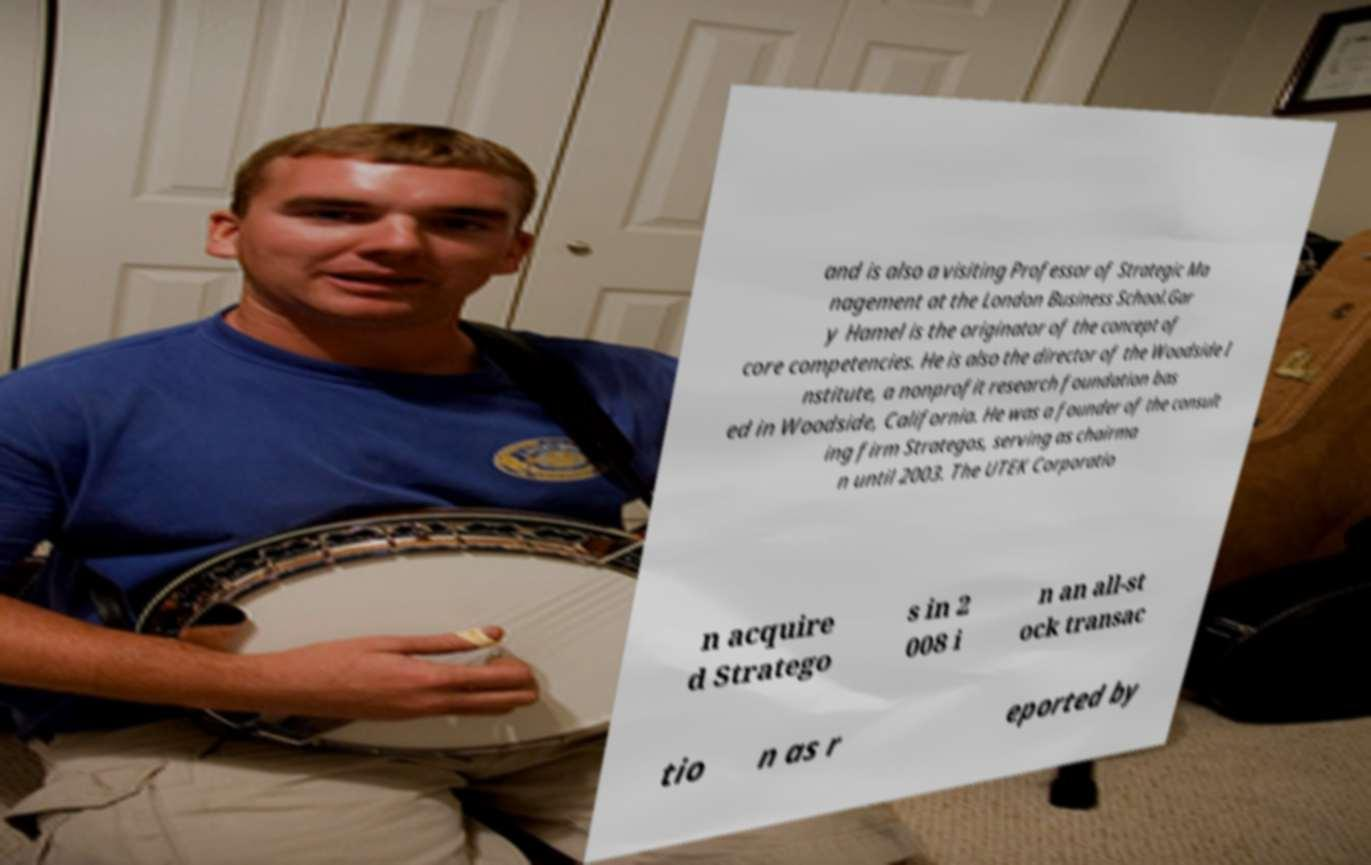Could you extract and type out the text from this image? and is also a visiting Professor of Strategic Ma nagement at the London Business School.Gar y Hamel is the originator of the concept of core competencies. He is also the director of the Woodside I nstitute, a nonprofit research foundation bas ed in Woodside, California. He was a founder of the consult ing firm Strategos, serving as chairma n until 2003. The UTEK Corporatio n acquire d Stratego s in 2 008 i n an all-st ock transac tio n as r eported by 